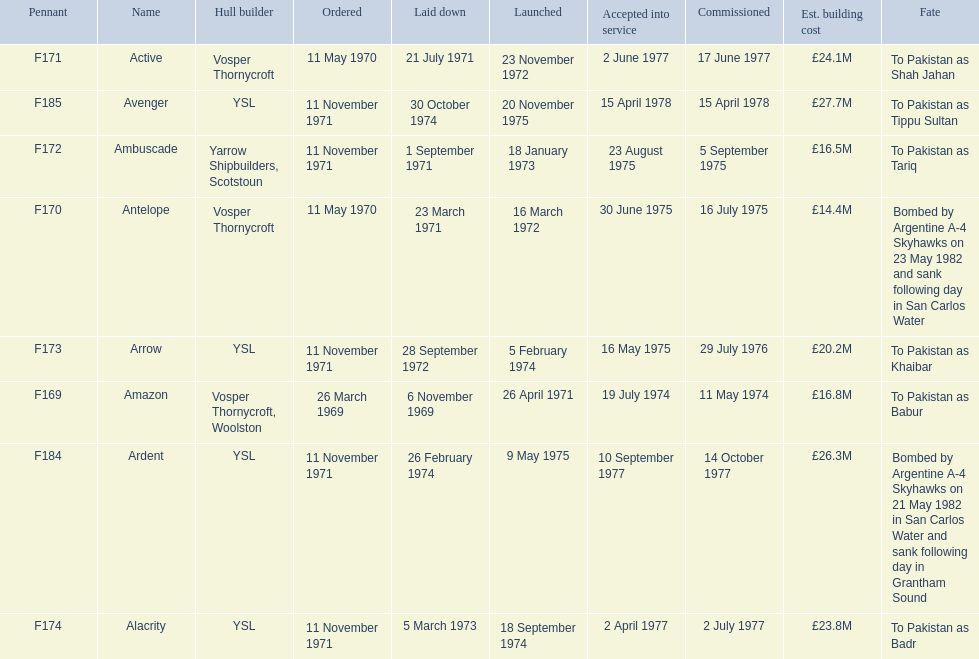Which type 21 frigate ships were to be built by ysl in the 1970s? Arrow, Alacrity, Ardent, Avenger. Of these ships, which one had the highest estimated building cost? Avenger. Could you help me parse every detail presented in this table? {'header': ['Pennant', 'Name', 'Hull builder', 'Ordered', 'Laid down', 'Launched', 'Accepted into service', 'Commissioned', 'Est. building cost', 'Fate'], 'rows': [['F171', 'Active', 'Vosper Thornycroft', '11 May 1970', '21 July 1971', '23 November 1972', '2 June 1977', '17 June 1977', '£24.1M', 'To Pakistan as Shah Jahan'], ['F185', 'Avenger', 'YSL', '11 November 1971', '30 October 1974', '20 November 1975', '15 April 1978', '15 April 1978', '£27.7M', 'To Pakistan as Tippu Sultan'], ['F172', 'Ambuscade', 'Yarrow Shipbuilders, Scotstoun', '11 November 1971', '1 September 1971', '18 January 1973', '23 August 1975', '5 September 1975', '£16.5M', 'To Pakistan as Tariq'], ['F170', 'Antelope', 'Vosper Thornycroft', '11 May 1970', '23 March 1971', '16 March 1972', '30 June 1975', '16 July 1975', '£14.4M', 'Bombed by Argentine A-4 Skyhawks on 23 May 1982 and sank following day in San Carlos Water'], ['F173', 'Arrow', 'YSL', '11 November 1971', '28 September 1972', '5 February 1974', '16 May 1975', '29 July 1976', '£20.2M', 'To Pakistan as Khaibar'], ['F169', 'Amazon', 'Vosper Thornycroft, Woolston', '26 March 1969', '6 November 1969', '26 April 1971', '19 July 1974', '11 May 1974', '£16.8M', 'To Pakistan as Babur'], ['F184', 'Ardent', 'YSL', '11 November 1971', '26 February 1974', '9 May 1975', '10 September 1977', '14 October 1977', '£26.3M', 'Bombed by Argentine A-4 Skyhawks on 21 May 1982 in San Carlos Water and sank following day in Grantham Sound'], ['F174', 'Alacrity', 'YSL', '11 November 1971', '5 March 1973', '18 September 1974', '2 April 1977', '2 July 1977', '£23.8M', 'To Pakistan as Badr']]} 